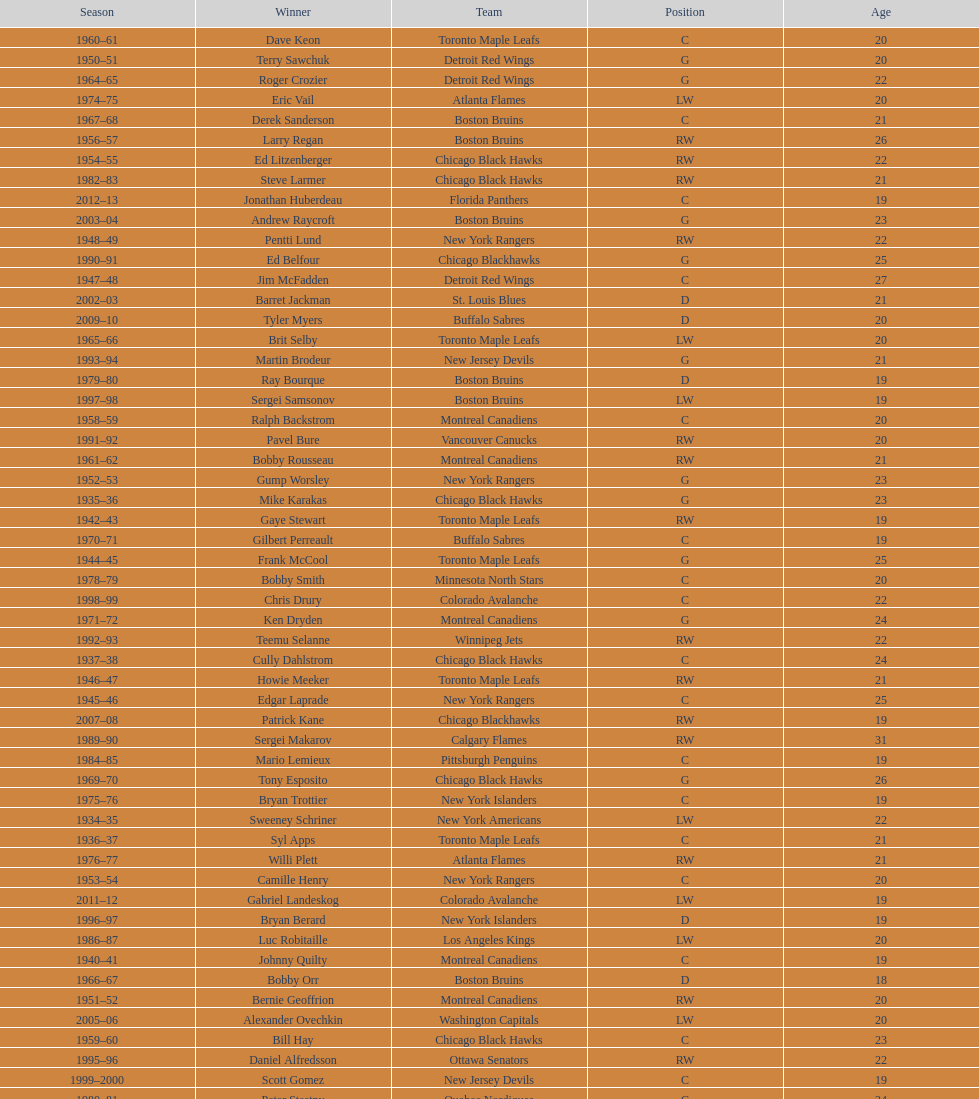Who was the first calder memorial trophy winner from the boston bruins? Frank Brimsek. 